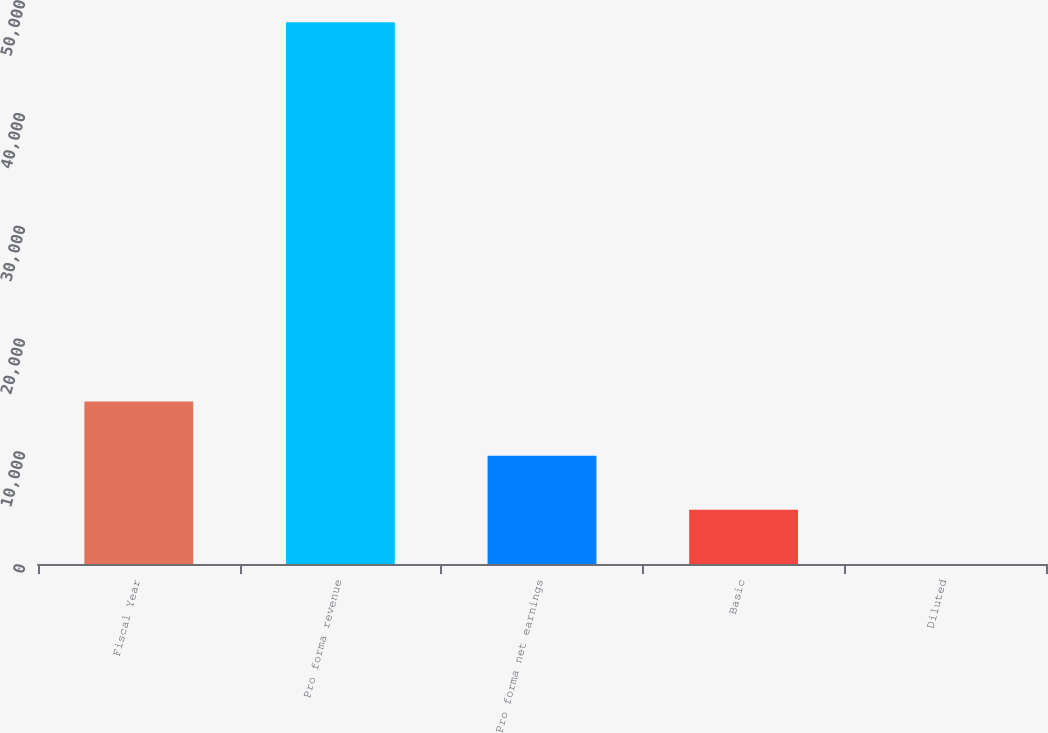<chart> <loc_0><loc_0><loc_500><loc_500><bar_chart><fcel>Fiscal Year<fcel>Pro forma revenue<fcel>Pro forma net earnings<fcel>Basic<fcel>Diluted<nl><fcel>14408<fcel>48021<fcel>9606.1<fcel>4804.24<fcel>2.38<nl></chart> 